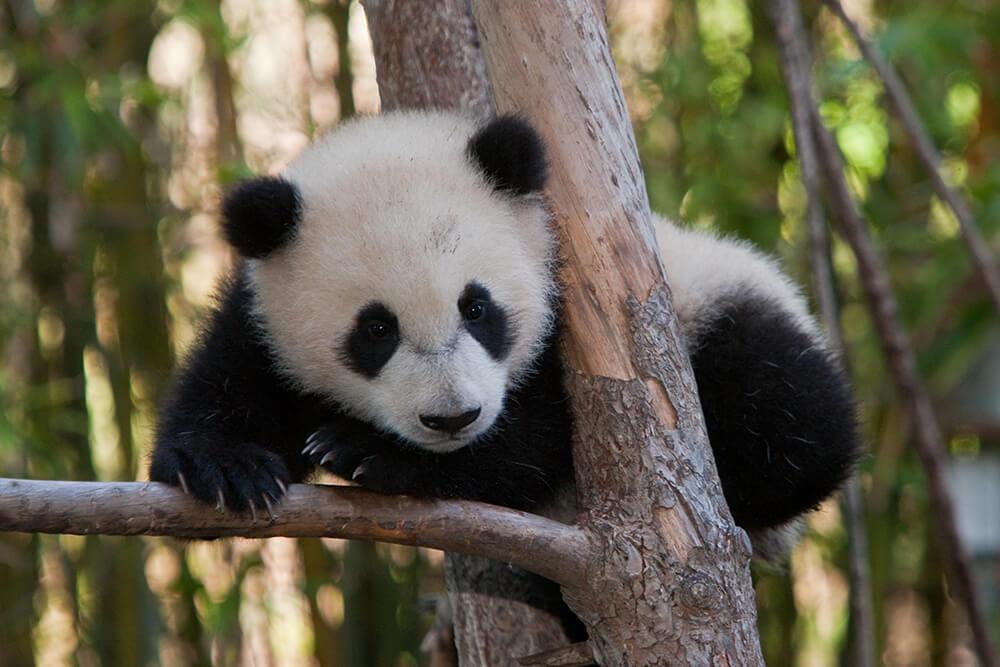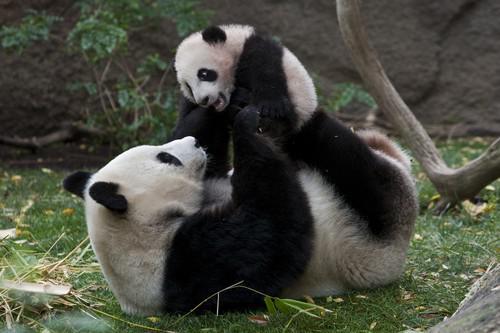The first image is the image on the left, the second image is the image on the right. For the images shown, is this caption "An image includes a panda at least partly on its back on green ground." true? Answer yes or no. Yes. The first image is the image on the left, the second image is the image on the right. Considering the images on both sides, is "A panda is resting its chin." valid? Answer yes or no. No. The first image is the image on the left, the second image is the image on the right. Examine the images to the left and right. Is the description "There are two black and white panda bears" accurate? Answer yes or no. No. The first image is the image on the left, the second image is the image on the right. Given the left and right images, does the statement "One of the pandas is on all fours." hold true? Answer yes or no. No. 